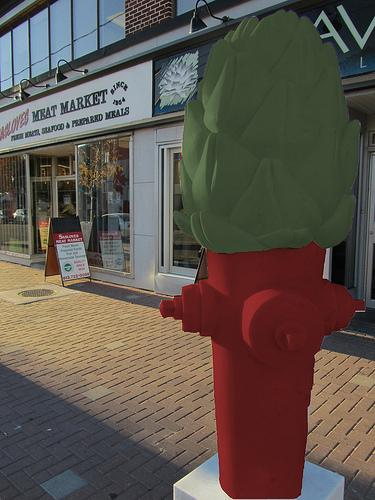Describe the scene on the sidewalk in the image. The sidewalk has a brick pattern with a round manhole cover, a red and white portable sign, and a few street lamps above it. Describe any visible reflections in the image. There are reflections of a tree and a car in the glass window of the store. List the main types of objects you see in the image. Red hydrant, brick building, sidewalk, glass window, street lamps, and a meat market sign. What is the purpose of the peculiar object sitting on top of the hydrant? There's an artichoke on top of the hydrant for a humorous or artistic effect. Mention the most prominent object in the image and its location. A large red hydrant is located near the center of the picture, sitting on a white base. Which object has been photoshopped into the image and where is it located? A large photoshopped fire hydrant is in the middle of the image near the sidewalk. Describe the storefront captured in the image. The storefront features a glass door and window, a meat market sign on top, and a reflection of a tree and a car in the window. Identify the type of sign outside a store and what it says. There's a white portable sign with the words "meat market" written on it in front of the store. Explain the architectural elements that are visible in the image. In the image, there's a brick building with red and white bricks, a row of windows, and a tower with a base and a pillar on the side. Mention the color and the location of the bricks noticeable in the image. The red bricks are on the building, in the top-left corner of the image, while white bricks are scattered among them. 